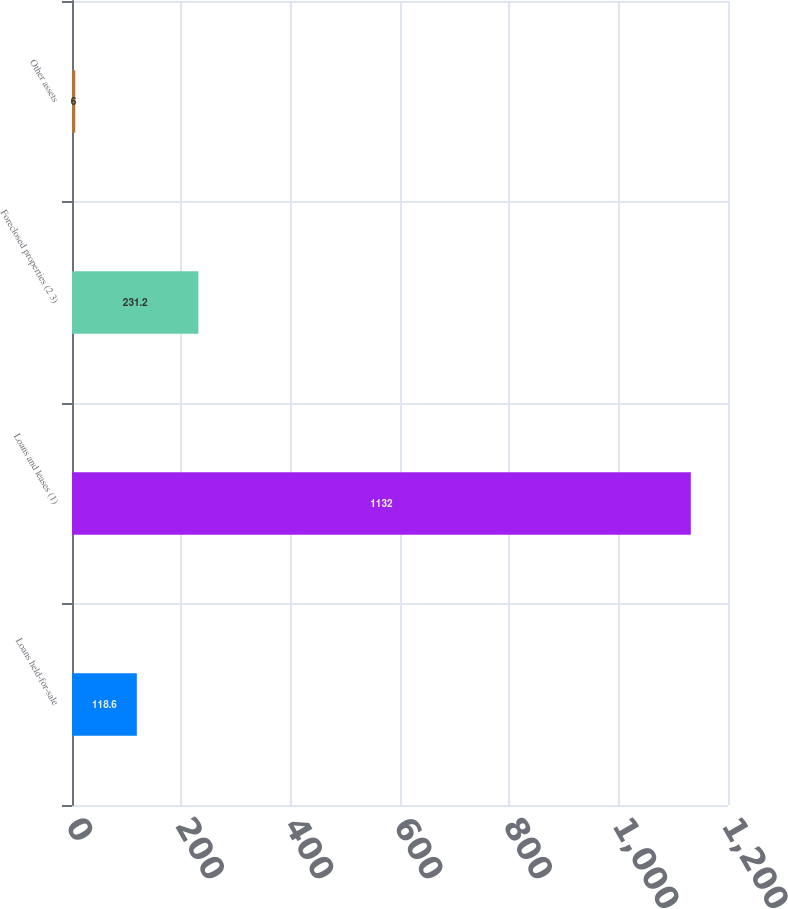Convert chart. <chart><loc_0><loc_0><loc_500><loc_500><bar_chart><fcel>Loans held-for-sale<fcel>Loans and leases (1)<fcel>Foreclosed properties (2 3)<fcel>Other assets<nl><fcel>118.6<fcel>1132<fcel>231.2<fcel>6<nl></chart> 